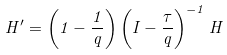<formula> <loc_0><loc_0><loc_500><loc_500>H ^ { \prime } = \left ( 1 - \frac { 1 } { q } \right ) \left ( I - \frac { \tau } { q } \right ) ^ { - 1 } H</formula> 